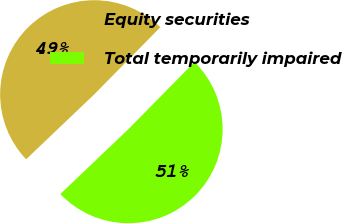<chart> <loc_0><loc_0><loc_500><loc_500><pie_chart><fcel>Equity securities<fcel>Total temporarily impaired<nl><fcel>49.49%<fcel>50.51%<nl></chart> 